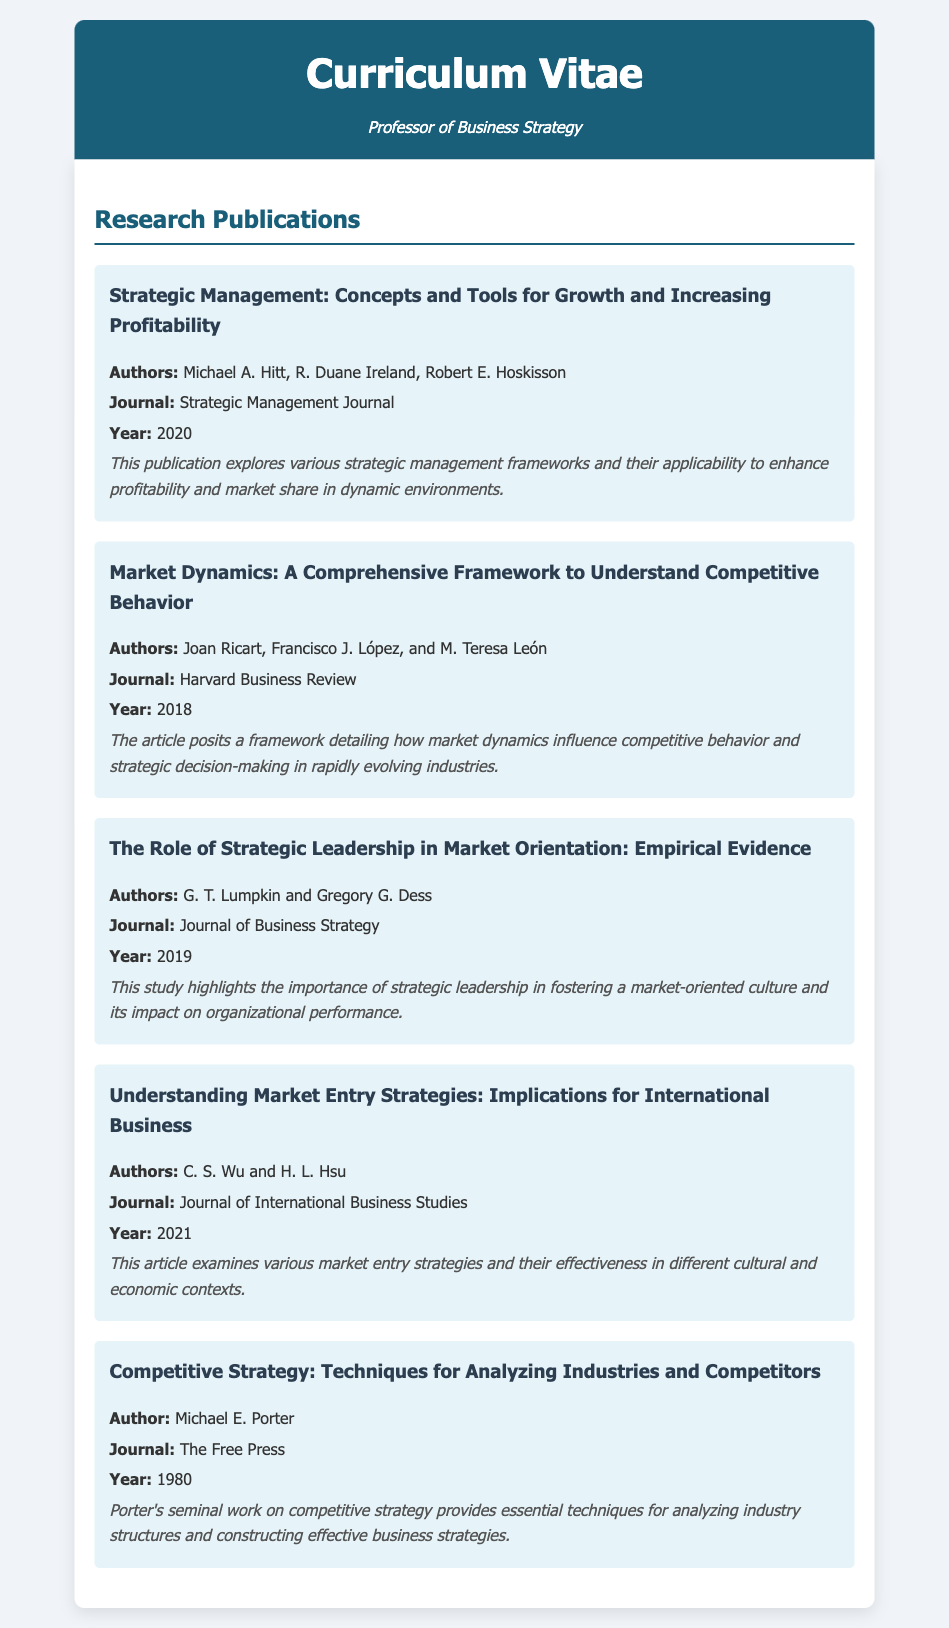What is the title of the first publication? The title of the first publication is provided in the document under Research Publications.
Answer: Strategic Management: Concepts and Tools for Growth and Increasing Profitability Who is one of the authors of the publication titled "Market Dynamics: A Comprehensive Framework to Understand Competitive Behavior"? The document lists multiple authors for this publication, and one of them can be extracted directly.
Answer: Joan Ricart In which journal was "The Role of Strategic Leadership in Market Orientation: Empirical Evidence" published? The document specifies the journal for each publication under Research Publications.
Answer: Journal of Business Strategy What year was "Understanding Market Entry Strategies: Implications for International Business" published? The publication year is included for each article in the document.
Answer: 2021 How many publications are listed under Research Publications? The total number of publications is determined by counting each entry in the section.
Answer: 5 Which publication discusses competitive strategy techniques? The title of the publication that focuses on competitive strategy techniques is found in the document.
Answer: Competitive Strategy: Techniques for Analyzing Industries and Competitors What is the main focus of the article titled "Competitive Strategy: Techniques for Analyzing Industries and Competitors"? This is inferred from the abstract provided for the publication in the document.
Answer: Analyzing industry structures Who authored the seminal work on competitive strategy? The author's name is listed directly for the publication in the document.
Answer: Michael E. Porter 